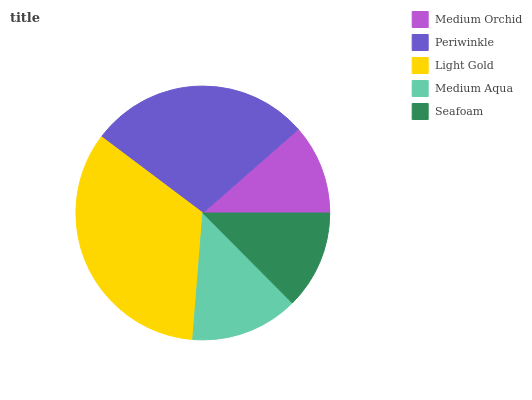Is Medium Orchid the minimum?
Answer yes or no. Yes. Is Light Gold the maximum?
Answer yes or no. Yes. Is Periwinkle the minimum?
Answer yes or no. No. Is Periwinkle the maximum?
Answer yes or no. No. Is Periwinkle greater than Medium Orchid?
Answer yes or no. Yes. Is Medium Orchid less than Periwinkle?
Answer yes or no. Yes. Is Medium Orchid greater than Periwinkle?
Answer yes or no. No. Is Periwinkle less than Medium Orchid?
Answer yes or no. No. Is Medium Aqua the high median?
Answer yes or no. Yes. Is Medium Aqua the low median?
Answer yes or no. Yes. Is Medium Orchid the high median?
Answer yes or no. No. Is Periwinkle the low median?
Answer yes or no. No. 